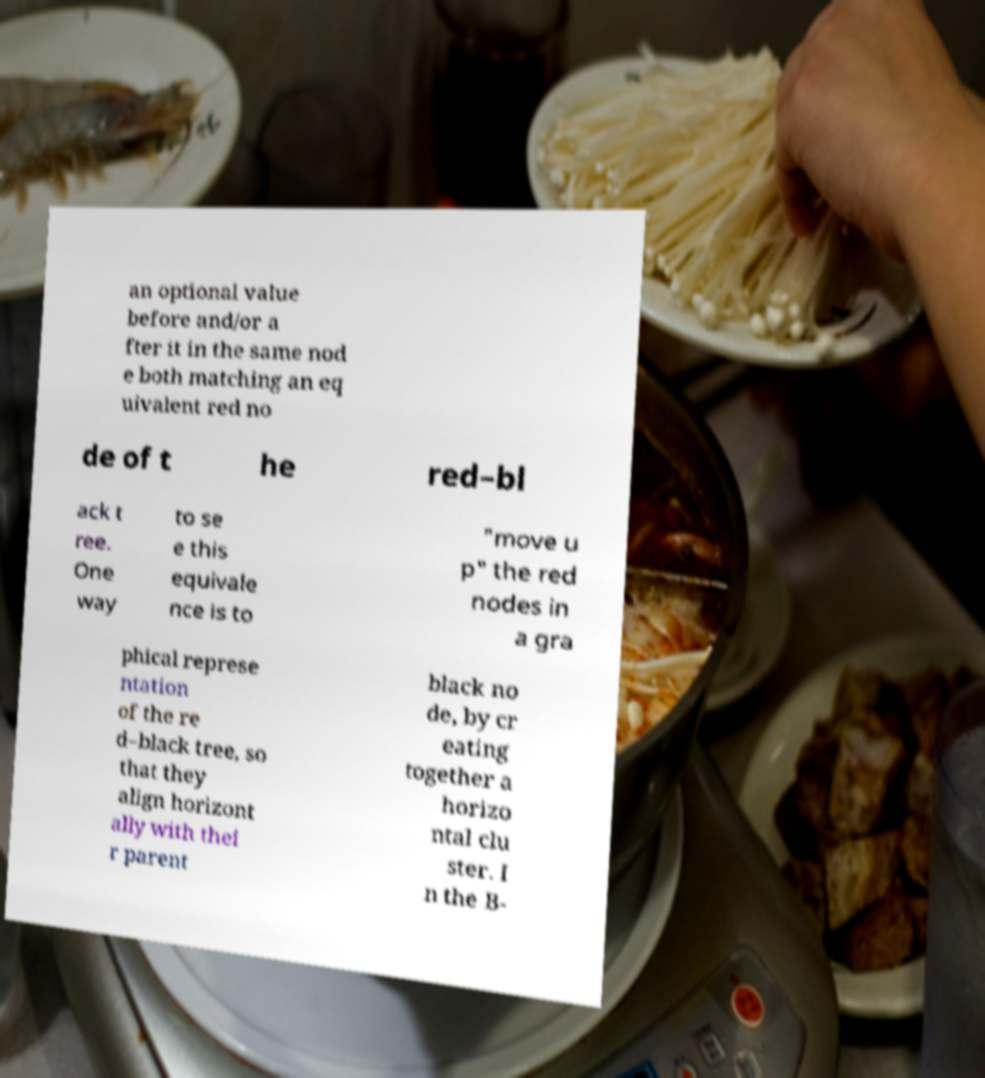Can you read and provide the text displayed in the image?This photo seems to have some interesting text. Can you extract and type it out for me? an optional value before and/or a fter it in the same nod e both matching an eq uivalent red no de of t he red–bl ack t ree. One way to se e this equivale nce is to "move u p" the red nodes in a gra phical represe ntation of the re d–black tree, so that they align horizont ally with thei r parent black no de, by cr eating together a horizo ntal clu ster. I n the B- 